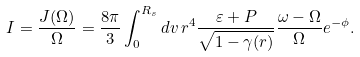<formula> <loc_0><loc_0><loc_500><loc_500>I = \frac { J ( \Omega ) } { \Omega } = \frac { 8 \pi } { 3 } \int ^ { R _ { s } } _ { 0 } d v \, r ^ { 4 } \frac { \varepsilon + P } { \sqrt { 1 - \gamma ( r ) } } \frac { \omega - \Omega } { \Omega } e ^ { - \phi } .</formula> 